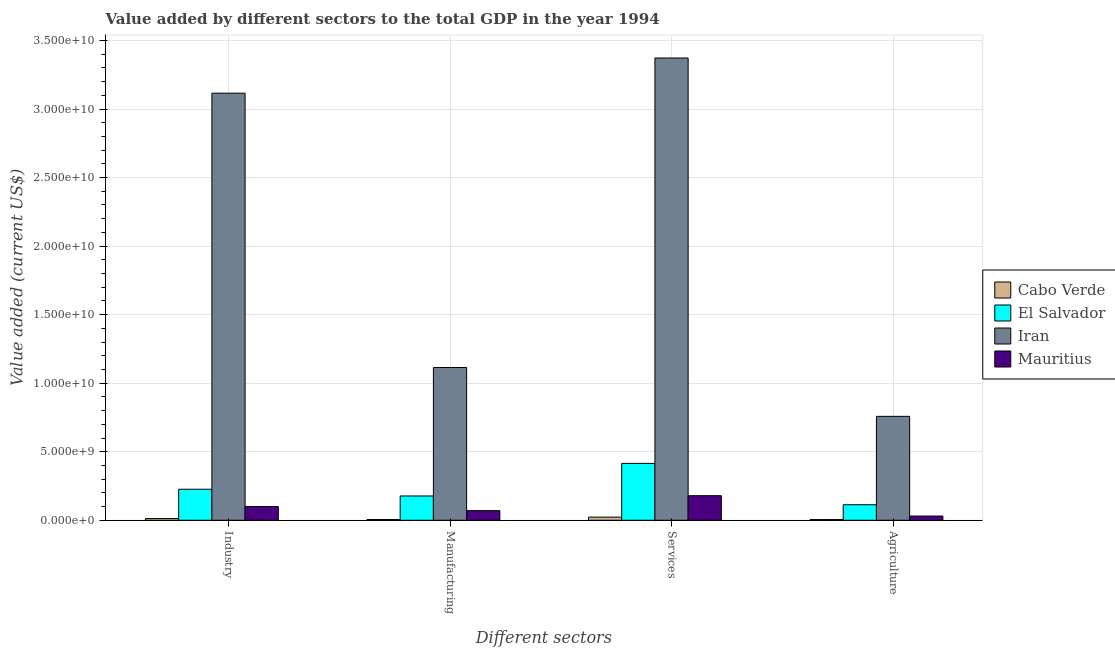How many different coloured bars are there?
Offer a very short reply. 4. How many groups of bars are there?
Give a very brief answer. 4. Are the number of bars on each tick of the X-axis equal?
Give a very brief answer. Yes. What is the label of the 1st group of bars from the left?
Your response must be concise. Industry. What is the value added by manufacturing sector in Cabo Verde?
Offer a terse response. 5.38e+07. Across all countries, what is the maximum value added by industrial sector?
Your answer should be compact. 3.12e+1. Across all countries, what is the minimum value added by industrial sector?
Offer a terse response. 1.24e+08. In which country was the value added by industrial sector maximum?
Your response must be concise. Iran. In which country was the value added by agricultural sector minimum?
Make the answer very short. Cabo Verde. What is the total value added by services sector in the graph?
Your response must be concise. 3.99e+1. What is the difference between the value added by services sector in Iran and that in Mauritius?
Ensure brevity in your answer.  3.19e+1. What is the difference between the value added by services sector in El Salvador and the value added by manufacturing sector in Cabo Verde?
Ensure brevity in your answer.  4.10e+09. What is the average value added by agricultural sector per country?
Keep it short and to the point. 2.27e+09. What is the difference between the value added by services sector and value added by manufacturing sector in Iran?
Provide a succinct answer. 2.26e+1. In how many countries, is the value added by industrial sector greater than 9000000000 US$?
Provide a succinct answer. 1. What is the ratio of the value added by industrial sector in Cabo Verde to that in Mauritius?
Your response must be concise. 0.12. Is the value added by services sector in Cabo Verde less than that in Mauritius?
Your answer should be compact. Yes. Is the difference between the value added by manufacturing sector in Iran and El Salvador greater than the difference between the value added by industrial sector in Iran and El Salvador?
Offer a terse response. No. What is the difference between the highest and the second highest value added by services sector?
Offer a very short reply. 2.96e+1. What is the difference between the highest and the lowest value added by services sector?
Your response must be concise. 3.35e+1. In how many countries, is the value added by industrial sector greater than the average value added by industrial sector taken over all countries?
Your answer should be compact. 1. Is the sum of the value added by industrial sector in Mauritius and Iran greater than the maximum value added by services sector across all countries?
Keep it short and to the point. No. What does the 1st bar from the left in Manufacturing represents?
Make the answer very short. Cabo Verde. What does the 2nd bar from the right in Services represents?
Provide a short and direct response. Iran. Are the values on the major ticks of Y-axis written in scientific E-notation?
Keep it short and to the point. Yes. Does the graph contain any zero values?
Your response must be concise. No. Does the graph contain grids?
Keep it short and to the point. Yes. Where does the legend appear in the graph?
Keep it short and to the point. Center right. What is the title of the graph?
Give a very brief answer. Value added by different sectors to the total GDP in the year 1994. Does "North America" appear as one of the legend labels in the graph?
Your response must be concise. No. What is the label or title of the X-axis?
Offer a terse response. Different sectors. What is the label or title of the Y-axis?
Your answer should be compact. Value added (current US$). What is the Value added (current US$) of Cabo Verde in Industry?
Your response must be concise. 1.24e+08. What is the Value added (current US$) of El Salvador in Industry?
Keep it short and to the point. 2.26e+09. What is the Value added (current US$) in Iran in Industry?
Provide a succinct answer. 3.12e+1. What is the Value added (current US$) in Mauritius in Industry?
Provide a short and direct response. 1.00e+09. What is the Value added (current US$) of Cabo Verde in Manufacturing?
Your response must be concise. 5.38e+07. What is the Value added (current US$) of El Salvador in Manufacturing?
Ensure brevity in your answer.  1.77e+09. What is the Value added (current US$) of Iran in Manufacturing?
Give a very brief answer. 1.11e+1. What is the Value added (current US$) of Mauritius in Manufacturing?
Ensure brevity in your answer.  7.02e+08. What is the Value added (current US$) in Cabo Verde in Services?
Ensure brevity in your answer.  2.30e+08. What is the Value added (current US$) of El Salvador in Services?
Your response must be concise. 4.15e+09. What is the Value added (current US$) in Iran in Services?
Provide a succinct answer. 3.37e+1. What is the Value added (current US$) in Mauritius in Services?
Your answer should be compact. 1.79e+09. What is the Value added (current US$) of Cabo Verde in Agriculture?
Your answer should be compact. 5.23e+07. What is the Value added (current US$) in El Salvador in Agriculture?
Your answer should be very brief. 1.13e+09. What is the Value added (current US$) in Iran in Agriculture?
Your answer should be very brief. 7.58e+09. What is the Value added (current US$) in Mauritius in Agriculture?
Keep it short and to the point. 3.08e+08. Across all Different sectors, what is the maximum Value added (current US$) in Cabo Verde?
Your answer should be compact. 2.30e+08. Across all Different sectors, what is the maximum Value added (current US$) in El Salvador?
Your response must be concise. 4.15e+09. Across all Different sectors, what is the maximum Value added (current US$) in Iran?
Your answer should be compact. 3.37e+1. Across all Different sectors, what is the maximum Value added (current US$) of Mauritius?
Your answer should be very brief. 1.79e+09. Across all Different sectors, what is the minimum Value added (current US$) of Cabo Verde?
Ensure brevity in your answer.  5.23e+07. Across all Different sectors, what is the minimum Value added (current US$) of El Salvador?
Ensure brevity in your answer.  1.13e+09. Across all Different sectors, what is the minimum Value added (current US$) in Iran?
Keep it short and to the point. 7.58e+09. Across all Different sectors, what is the minimum Value added (current US$) of Mauritius?
Provide a short and direct response. 3.08e+08. What is the total Value added (current US$) of Cabo Verde in the graph?
Your answer should be compact. 4.60e+08. What is the total Value added (current US$) of El Salvador in the graph?
Your answer should be very brief. 9.32e+09. What is the total Value added (current US$) in Iran in the graph?
Keep it short and to the point. 8.36e+1. What is the total Value added (current US$) in Mauritius in the graph?
Your answer should be compact. 3.80e+09. What is the difference between the Value added (current US$) in Cabo Verde in Industry and that in Manufacturing?
Offer a terse response. 7.04e+07. What is the difference between the Value added (current US$) of El Salvador in Industry and that in Manufacturing?
Your response must be concise. 4.91e+08. What is the difference between the Value added (current US$) in Iran in Industry and that in Manufacturing?
Your response must be concise. 2.00e+1. What is the difference between the Value added (current US$) in Mauritius in Industry and that in Manufacturing?
Provide a succinct answer. 2.99e+08. What is the difference between the Value added (current US$) of Cabo Verde in Industry and that in Services?
Give a very brief answer. -1.06e+08. What is the difference between the Value added (current US$) of El Salvador in Industry and that in Services?
Make the answer very short. -1.89e+09. What is the difference between the Value added (current US$) in Iran in Industry and that in Services?
Offer a terse response. -2.57e+09. What is the difference between the Value added (current US$) in Mauritius in Industry and that in Services?
Your answer should be very brief. -7.92e+08. What is the difference between the Value added (current US$) of Cabo Verde in Industry and that in Agriculture?
Offer a terse response. 7.20e+07. What is the difference between the Value added (current US$) in El Salvador in Industry and that in Agriculture?
Ensure brevity in your answer.  1.13e+09. What is the difference between the Value added (current US$) of Iran in Industry and that in Agriculture?
Your answer should be very brief. 2.36e+1. What is the difference between the Value added (current US$) of Mauritius in Industry and that in Agriculture?
Keep it short and to the point. 6.93e+08. What is the difference between the Value added (current US$) in Cabo Verde in Manufacturing and that in Services?
Your response must be concise. -1.76e+08. What is the difference between the Value added (current US$) of El Salvador in Manufacturing and that in Services?
Your answer should be compact. -2.38e+09. What is the difference between the Value added (current US$) of Iran in Manufacturing and that in Services?
Your answer should be very brief. -2.26e+1. What is the difference between the Value added (current US$) in Mauritius in Manufacturing and that in Services?
Your answer should be compact. -1.09e+09. What is the difference between the Value added (current US$) of Cabo Verde in Manufacturing and that in Agriculture?
Offer a very short reply. 1.56e+06. What is the difference between the Value added (current US$) of El Salvador in Manufacturing and that in Agriculture?
Your response must be concise. 6.38e+08. What is the difference between the Value added (current US$) of Iran in Manufacturing and that in Agriculture?
Offer a very short reply. 3.56e+09. What is the difference between the Value added (current US$) of Mauritius in Manufacturing and that in Agriculture?
Provide a short and direct response. 3.94e+08. What is the difference between the Value added (current US$) of Cabo Verde in Services and that in Agriculture?
Ensure brevity in your answer.  1.78e+08. What is the difference between the Value added (current US$) in El Salvador in Services and that in Agriculture?
Ensure brevity in your answer.  3.02e+09. What is the difference between the Value added (current US$) of Iran in Services and that in Agriculture?
Give a very brief answer. 2.61e+1. What is the difference between the Value added (current US$) of Mauritius in Services and that in Agriculture?
Offer a very short reply. 1.48e+09. What is the difference between the Value added (current US$) in Cabo Verde in Industry and the Value added (current US$) in El Salvador in Manufacturing?
Provide a succinct answer. -1.65e+09. What is the difference between the Value added (current US$) in Cabo Verde in Industry and the Value added (current US$) in Iran in Manufacturing?
Offer a terse response. -1.10e+1. What is the difference between the Value added (current US$) in Cabo Verde in Industry and the Value added (current US$) in Mauritius in Manufacturing?
Make the answer very short. -5.78e+08. What is the difference between the Value added (current US$) in El Salvador in Industry and the Value added (current US$) in Iran in Manufacturing?
Your answer should be compact. -8.88e+09. What is the difference between the Value added (current US$) of El Salvador in Industry and the Value added (current US$) of Mauritius in Manufacturing?
Keep it short and to the point. 1.56e+09. What is the difference between the Value added (current US$) in Iran in Industry and the Value added (current US$) in Mauritius in Manufacturing?
Give a very brief answer. 3.05e+1. What is the difference between the Value added (current US$) in Cabo Verde in Industry and the Value added (current US$) in El Salvador in Services?
Provide a short and direct response. -4.03e+09. What is the difference between the Value added (current US$) of Cabo Verde in Industry and the Value added (current US$) of Iran in Services?
Give a very brief answer. -3.36e+1. What is the difference between the Value added (current US$) of Cabo Verde in Industry and the Value added (current US$) of Mauritius in Services?
Give a very brief answer. -1.67e+09. What is the difference between the Value added (current US$) in El Salvador in Industry and the Value added (current US$) in Iran in Services?
Offer a very short reply. -3.15e+1. What is the difference between the Value added (current US$) in El Salvador in Industry and the Value added (current US$) in Mauritius in Services?
Keep it short and to the point. 4.70e+08. What is the difference between the Value added (current US$) in Iran in Industry and the Value added (current US$) in Mauritius in Services?
Offer a terse response. 2.94e+1. What is the difference between the Value added (current US$) of Cabo Verde in Industry and the Value added (current US$) of El Salvador in Agriculture?
Ensure brevity in your answer.  -1.01e+09. What is the difference between the Value added (current US$) of Cabo Verde in Industry and the Value added (current US$) of Iran in Agriculture?
Provide a succinct answer. -7.46e+09. What is the difference between the Value added (current US$) of Cabo Verde in Industry and the Value added (current US$) of Mauritius in Agriculture?
Provide a short and direct response. -1.84e+08. What is the difference between the Value added (current US$) in El Salvador in Industry and the Value added (current US$) in Iran in Agriculture?
Ensure brevity in your answer.  -5.32e+09. What is the difference between the Value added (current US$) of El Salvador in Industry and the Value added (current US$) of Mauritius in Agriculture?
Offer a terse response. 1.95e+09. What is the difference between the Value added (current US$) in Iran in Industry and the Value added (current US$) in Mauritius in Agriculture?
Ensure brevity in your answer.  3.08e+1. What is the difference between the Value added (current US$) of Cabo Verde in Manufacturing and the Value added (current US$) of El Salvador in Services?
Keep it short and to the point. -4.10e+09. What is the difference between the Value added (current US$) in Cabo Verde in Manufacturing and the Value added (current US$) in Iran in Services?
Your response must be concise. -3.37e+1. What is the difference between the Value added (current US$) of Cabo Verde in Manufacturing and the Value added (current US$) of Mauritius in Services?
Your answer should be compact. -1.74e+09. What is the difference between the Value added (current US$) of El Salvador in Manufacturing and the Value added (current US$) of Iran in Services?
Your answer should be compact. -3.20e+1. What is the difference between the Value added (current US$) of El Salvador in Manufacturing and the Value added (current US$) of Mauritius in Services?
Provide a short and direct response. -2.13e+07. What is the difference between the Value added (current US$) of Iran in Manufacturing and the Value added (current US$) of Mauritius in Services?
Provide a short and direct response. 9.35e+09. What is the difference between the Value added (current US$) of Cabo Verde in Manufacturing and the Value added (current US$) of El Salvador in Agriculture?
Your answer should be compact. -1.08e+09. What is the difference between the Value added (current US$) in Cabo Verde in Manufacturing and the Value added (current US$) in Iran in Agriculture?
Offer a terse response. -7.53e+09. What is the difference between the Value added (current US$) in Cabo Verde in Manufacturing and the Value added (current US$) in Mauritius in Agriculture?
Provide a succinct answer. -2.55e+08. What is the difference between the Value added (current US$) of El Salvador in Manufacturing and the Value added (current US$) of Iran in Agriculture?
Offer a very short reply. -5.81e+09. What is the difference between the Value added (current US$) of El Salvador in Manufacturing and the Value added (current US$) of Mauritius in Agriculture?
Ensure brevity in your answer.  1.46e+09. What is the difference between the Value added (current US$) in Iran in Manufacturing and the Value added (current US$) in Mauritius in Agriculture?
Offer a terse response. 1.08e+1. What is the difference between the Value added (current US$) in Cabo Verde in Services and the Value added (current US$) in El Salvador in Agriculture?
Ensure brevity in your answer.  -9.03e+08. What is the difference between the Value added (current US$) in Cabo Verde in Services and the Value added (current US$) in Iran in Agriculture?
Ensure brevity in your answer.  -7.35e+09. What is the difference between the Value added (current US$) in Cabo Verde in Services and the Value added (current US$) in Mauritius in Agriculture?
Your answer should be very brief. -7.83e+07. What is the difference between the Value added (current US$) in El Salvador in Services and the Value added (current US$) in Iran in Agriculture?
Make the answer very short. -3.43e+09. What is the difference between the Value added (current US$) of El Salvador in Services and the Value added (current US$) of Mauritius in Agriculture?
Provide a short and direct response. 3.84e+09. What is the difference between the Value added (current US$) in Iran in Services and the Value added (current US$) in Mauritius in Agriculture?
Provide a short and direct response. 3.34e+1. What is the average Value added (current US$) in Cabo Verde per Different sectors?
Your answer should be compact. 1.15e+08. What is the average Value added (current US$) in El Salvador per Different sectors?
Give a very brief answer. 2.33e+09. What is the average Value added (current US$) in Iran per Different sectors?
Offer a very short reply. 2.09e+1. What is the average Value added (current US$) of Mauritius per Different sectors?
Ensure brevity in your answer.  9.51e+08. What is the difference between the Value added (current US$) in Cabo Verde and Value added (current US$) in El Salvador in Industry?
Your response must be concise. -2.14e+09. What is the difference between the Value added (current US$) of Cabo Verde and Value added (current US$) of Iran in Industry?
Provide a succinct answer. -3.10e+1. What is the difference between the Value added (current US$) of Cabo Verde and Value added (current US$) of Mauritius in Industry?
Your answer should be compact. -8.77e+08. What is the difference between the Value added (current US$) in El Salvador and Value added (current US$) in Iran in Industry?
Provide a short and direct response. -2.89e+1. What is the difference between the Value added (current US$) of El Salvador and Value added (current US$) of Mauritius in Industry?
Offer a terse response. 1.26e+09. What is the difference between the Value added (current US$) of Iran and Value added (current US$) of Mauritius in Industry?
Your response must be concise. 3.02e+1. What is the difference between the Value added (current US$) in Cabo Verde and Value added (current US$) in El Salvador in Manufacturing?
Provide a short and direct response. -1.72e+09. What is the difference between the Value added (current US$) in Cabo Verde and Value added (current US$) in Iran in Manufacturing?
Make the answer very short. -1.11e+1. What is the difference between the Value added (current US$) of Cabo Verde and Value added (current US$) of Mauritius in Manufacturing?
Make the answer very short. -6.48e+08. What is the difference between the Value added (current US$) in El Salvador and Value added (current US$) in Iran in Manufacturing?
Provide a short and direct response. -9.37e+09. What is the difference between the Value added (current US$) of El Salvador and Value added (current US$) of Mauritius in Manufacturing?
Offer a terse response. 1.07e+09. What is the difference between the Value added (current US$) of Iran and Value added (current US$) of Mauritius in Manufacturing?
Your answer should be very brief. 1.04e+1. What is the difference between the Value added (current US$) of Cabo Verde and Value added (current US$) of El Salvador in Services?
Give a very brief answer. -3.92e+09. What is the difference between the Value added (current US$) of Cabo Verde and Value added (current US$) of Iran in Services?
Make the answer very short. -3.35e+1. What is the difference between the Value added (current US$) of Cabo Verde and Value added (current US$) of Mauritius in Services?
Keep it short and to the point. -1.56e+09. What is the difference between the Value added (current US$) of El Salvador and Value added (current US$) of Iran in Services?
Your answer should be compact. -2.96e+1. What is the difference between the Value added (current US$) of El Salvador and Value added (current US$) of Mauritius in Services?
Provide a short and direct response. 2.36e+09. What is the difference between the Value added (current US$) of Iran and Value added (current US$) of Mauritius in Services?
Offer a terse response. 3.19e+1. What is the difference between the Value added (current US$) in Cabo Verde and Value added (current US$) in El Salvador in Agriculture?
Offer a very short reply. -1.08e+09. What is the difference between the Value added (current US$) of Cabo Verde and Value added (current US$) of Iran in Agriculture?
Your answer should be compact. -7.53e+09. What is the difference between the Value added (current US$) in Cabo Verde and Value added (current US$) in Mauritius in Agriculture?
Your response must be concise. -2.56e+08. What is the difference between the Value added (current US$) of El Salvador and Value added (current US$) of Iran in Agriculture?
Your answer should be very brief. -6.45e+09. What is the difference between the Value added (current US$) in El Salvador and Value added (current US$) in Mauritius in Agriculture?
Offer a terse response. 8.25e+08. What is the difference between the Value added (current US$) in Iran and Value added (current US$) in Mauritius in Agriculture?
Make the answer very short. 7.27e+09. What is the ratio of the Value added (current US$) in Cabo Verde in Industry to that in Manufacturing?
Make the answer very short. 2.31. What is the ratio of the Value added (current US$) of El Salvador in Industry to that in Manufacturing?
Make the answer very short. 1.28. What is the ratio of the Value added (current US$) in Iran in Industry to that in Manufacturing?
Your answer should be very brief. 2.8. What is the ratio of the Value added (current US$) of Mauritius in Industry to that in Manufacturing?
Provide a succinct answer. 1.43. What is the ratio of the Value added (current US$) in Cabo Verde in Industry to that in Services?
Your answer should be very brief. 0.54. What is the ratio of the Value added (current US$) of El Salvador in Industry to that in Services?
Provide a succinct answer. 0.55. What is the ratio of the Value added (current US$) of Iran in Industry to that in Services?
Your answer should be very brief. 0.92. What is the ratio of the Value added (current US$) in Mauritius in Industry to that in Services?
Offer a very short reply. 0.56. What is the ratio of the Value added (current US$) in Cabo Verde in Industry to that in Agriculture?
Your response must be concise. 2.38. What is the ratio of the Value added (current US$) in El Salvador in Industry to that in Agriculture?
Give a very brief answer. 2. What is the ratio of the Value added (current US$) in Iran in Industry to that in Agriculture?
Make the answer very short. 4.11. What is the ratio of the Value added (current US$) of Mauritius in Industry to that in Agriculture?
Make the answer very short. 3.25. What is the ratio of the Value added (current US$) of Cabo Verde in Manufacturing to that in Services?
Ensure brevity in your answer.  0.23. What is the ratio of the Value added (current US$) in El Salvador in Manufacturing to that in Services?
Offer a very short reply. 0.43. What is the ratio of the Value added (current US$) in Iran in Manufacturing to that in Services?
Offer a terse response. 0.33. What is the ratio of the Value added (current US$) of Mauritius in Manufacturing to that in Services?
Offer a very short reply. 0.39. What is the ratio of the Value added (current US$) of Cabo Verde in Manufacturing to that in Agriculture?
Ensure brevity in your answer.  1.03. What is the ratio of the Value added (current US$) of El Salvador in Manufacturing to that in Agriculture?
Give a very brief answer. 1.56. What is the ratio of the Value added (current US$) in Iran in Manufacturing to that in Agriculture?
Offer a very short reply. 1.47. What is the ratio of the Value added (current US$) of Mauritius in Manufacturing to that in Agriculture?
Provide a succinct answer. 2.28. What is the ratio of the Value added (current US$) of Cabo Verde in Services to that in Agriculture?
Offer a terse response. 4.4. What is the ratio of the Value added (current US$) in El Salvador in Services to that in Agriculture?
Your answer should be compact. 3.66. What is the ratio of the Value added (current US$) in Iran in Services to that in Agriculture?
Keep it short and to the point. 4.45. What is the ratio of the Value added (current US$) in Mauritius in Services to that in Agriculture?
Provide a succinct answer. 5.81. What is the difference between the highest and the second highest Value added (current US$) in Cabo Verde?
Offer a very short reply. 1.06e+08. What is the difference between the highest and the second highest Value added (current US$) of El Salvador?
Offer a very short reply. 1.89e+09. What is the difference between the highest and the second highest Value added (current US$) of Iran?
Make the answer very short. 2.57e+09. What is the difference between the highest and the second highest Value added (current US$) in Mauritius?
Ensure brevity in your answer.  7.92e+08. What is the difference between the highest and the lowest Value added (current US$) of Cabo Verde?
Your answer should be very brief. 1.78e+08. What is the difference between the highest and the lowest Value added (current US$) of El Salvador?
Keep it short and to the point. 3.02e+09. What is the difference between the highest and the lowest Value added (current US$) of Iran?
Your answer should be compact. 2.61e+1. What is the difference between the highest and the lowest Value added (current US$) of Mauritius?
Provide a short and direct response. 1.48e+09. 